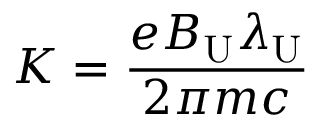<formula> <loc_0><loc_0><loc_500><loc_500>K = \frac { e B _ { U } \lambda _ { U } } { 2 \pi m c }</formula> 